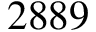<formula> <loc_0><loc_0><loc_500><loc_500>2 8 8 9</formula> 